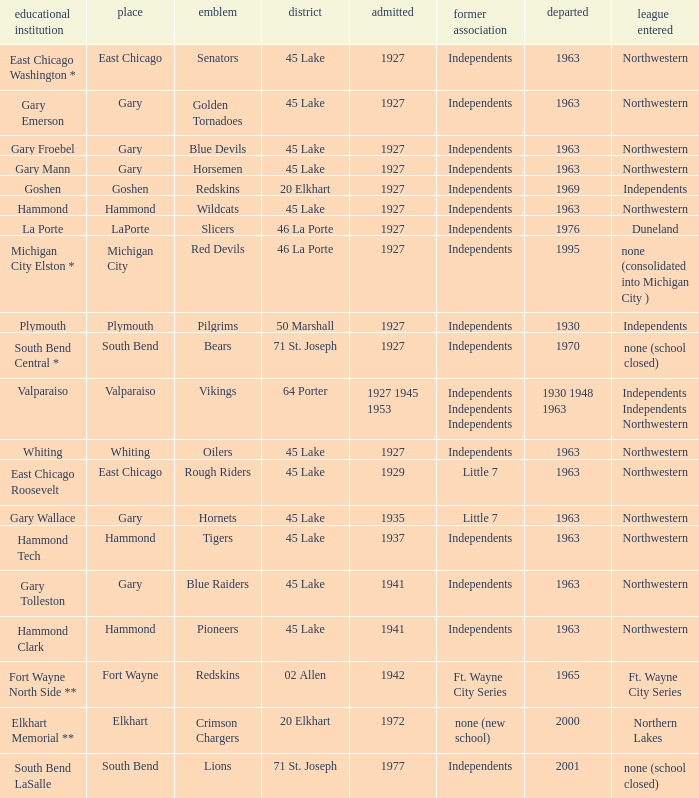Which conference held at School of whiting? Independents. 